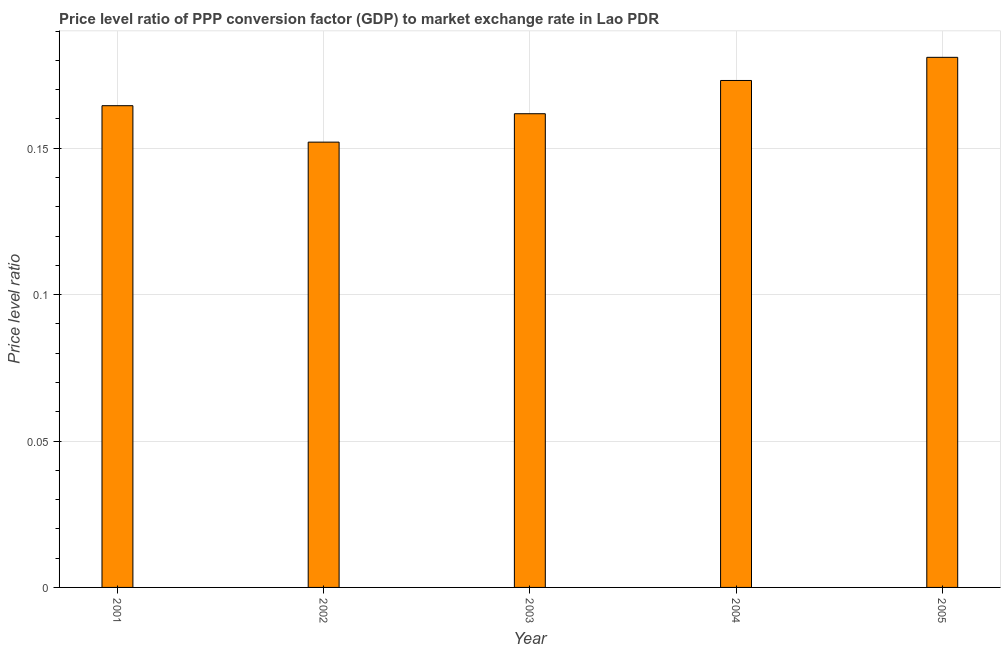Does the graph contain grids?
Your response must be concise. Yes. What is the title of the graph?
Offer a very short reply. Price level ratio of PPP conversion factor (GDP) to market exchange rate in Lao PDR. What is the label or title of the Y-axis?
Your answer should be very brief. Price level ratio. What is the price level ratio in 2005?
Provide a short and direct response. 0.18. Across all years, what is the maximum price level ratio?
Offer a very short reply. 0.18. Across all years, what is the minimum price level ratio?
Your response must be concise. 0.15. In which year was the price level ratio minimum?
Make the answer very short. 2002. What is the sum of the price level ratio?
Make the answer very short. 0.83. What is the difference between the price level ratio in 2002 and 2004?
Your answer should be very brief. -0.02. What is the average price level ratio per year?
Offer a very short reply. 0.17. What is the median price level ratio?
Give a very brief answer. 0.16. Do a majority of the years between 2002 and 2003 (inclusive) have price level ratio greater than 0.02 ?
Make the answer very short. Yes. What is the ratio of the price level ratio in 2002 to that in 2003?
Ensure brevity in your answer.  0.94. What is the difference between the highest and the second highest price level ratio?
Keep it short and to the point. 0.01. What is the difference between the highest and the lowest price level ratio?
Your answer should be very brief. 0.03. In how many years, is the price level ratio greater than the average price level ratio taken over all years?
Give a very brief answer. 2. Are the values on the major ticks of Y-axis written in scientific E-notation?
Provide a short and direct response. No. What is the Price level ratio in 2001?
Your answer should be compact. 0.16. What is the Price level ratio in 2002?
Keep it short and to the point. 0.15. What is the Price level ratio in 2003?
Keep it short and to the point. 0.16. What is the Price level ratio of 2004?
Your response must be concise. 0.17. What is the Price level ratio of 2005?
Ensure brevity in your answer.  0.18. What is the difference between the Price level ratio in 2001 and 2002?
Your answer should be compact. 0.01. What is the difference between the Price level ratio in 2001 and 2003?
Your response must be concise. 0. What is the difference between the Price level ratio in 2001 and 2004?
Ensure brevity in your answer.  -0.01. What is the difference between the Price level ratio in 2001 and 2005?
Your response must be concise. -0.02. What is the difference between the Price level ratio in 2002 and 2003?
Make the answer very short. -0.01. What is the difference between the Price level ratio in 2002 and 2004?
Your answer should be compact. -0.02. What is the difference between the Price level ratio in 2002 and 2005?
Offer a very short reply. -0.03. What is the difference between the Price level ratio in 2003 and 2004?
Offer a very short reply. -0.01. What is the difference between the Price level ratio in 2003 and 2005?
Offer a very short reply. -0.02. What is the difference between the Price level ratio in 2004 and 2005?
Keep it short and to the point. -0.01. What is the ratio of the Price level ratio in 2001 to that in 2002?
Make the answer very short. 1.08. What is the ratio of the Price level ratio in 2001 to that in 2004?
Your answer should be compact. 0.95. What is the ratio of the Price level ratio in 2001 to that in 2005?
Give a very brief answer. 0.91. What is the ratio of the Price level ratio in 2002 to that in 2003?
Make the answer very short. 0.94. What is the ratio of the Price level ratio in 2002 to that in 2004?
Your answer should be very brief. 0.88. What is the ratio of the Price level ratio in 2002 to that in 2005?
Offer a very short reply. 0.84. What is the ratio of the Price level ratio in 2003 to that in 2004?
Your answer should be compact. 0.93. What is the ratio of the Price level ratio in 2003 to that in 2005?
Provide a succinct answer. 0.89. What is the ratio of the Price level ratio in 2004 to that in 2005?
Provide a short and direct response. 0.96. 